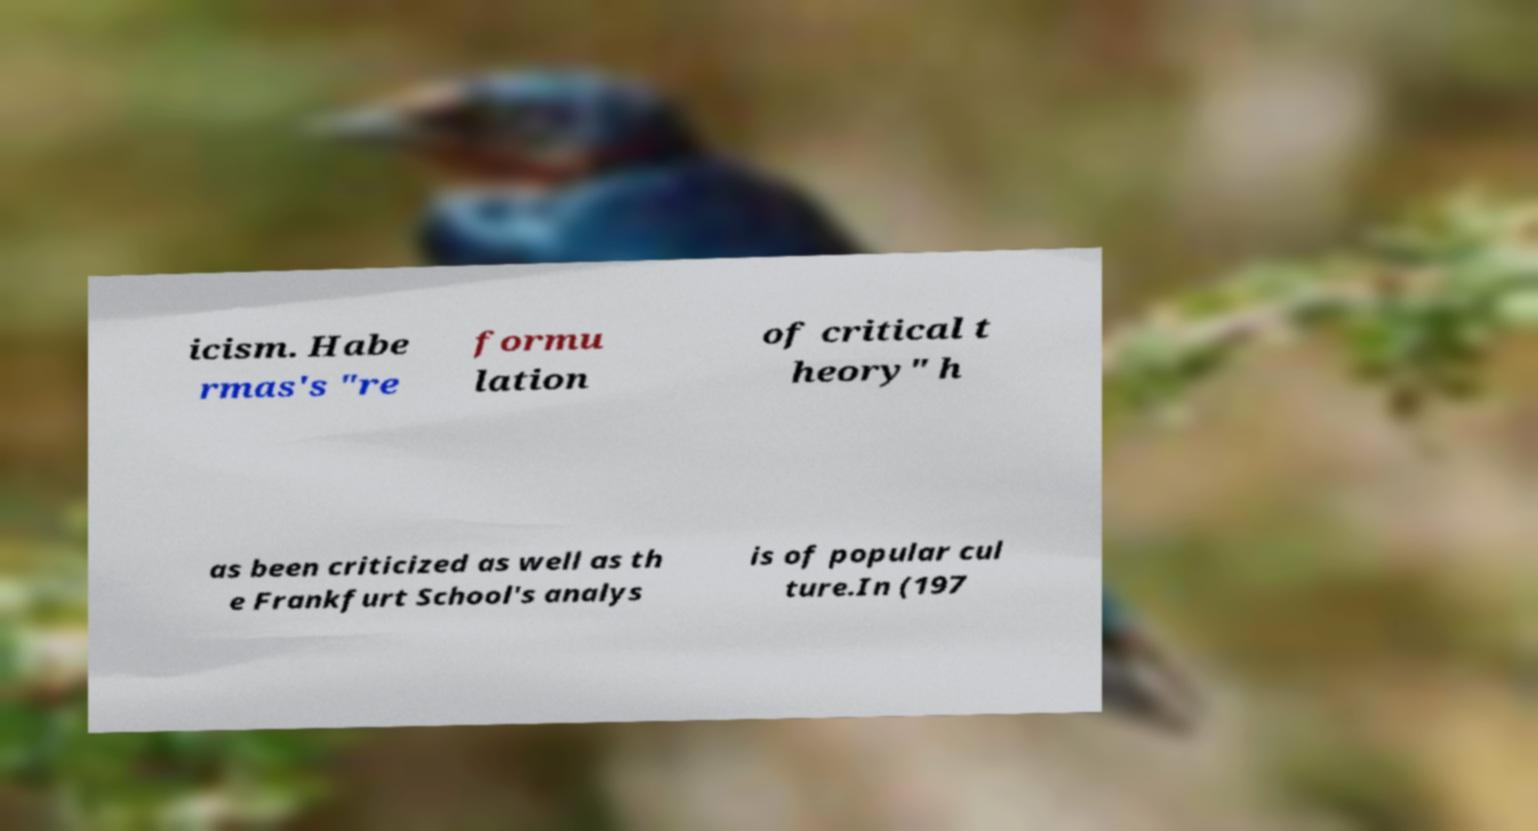I need the written content from this picture converted into text. Can you do that? icism. Habe rmas's "re formu lation of critical t heory" h as been criticized as well as th e Frankfurt School's analys is of popular cul ture.In (197 